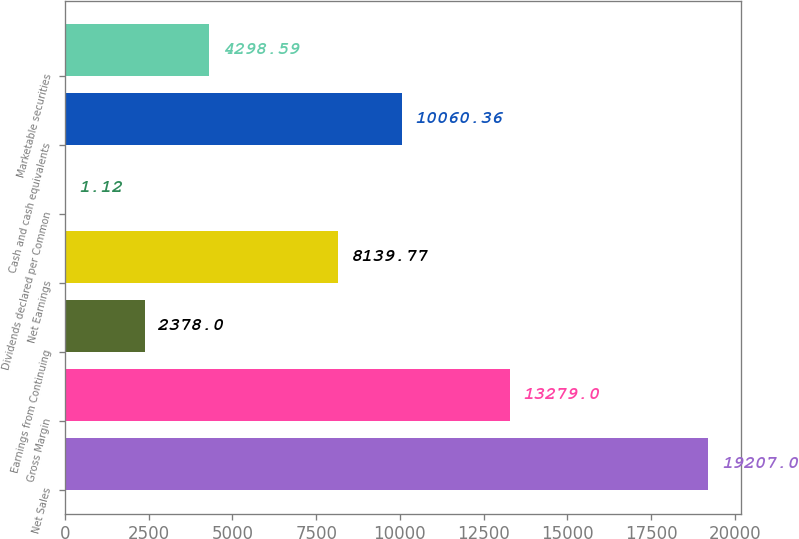Convert chart. <chart><loc_0><loc_0><loc_500><loc_500><bar_chart><fcel>Net Sales<fcel>Gross Margin<fcel>Earnings from Continuing<fcel>Net Earnings<fcel>Dividends declared per Common<fcel>Cash and cash equivalents<fcel>Marketable securities<nl><fcel>19207<fcel>13279<fcel>2378<fcel>8139.77<fcel>1.12<fcel>10060.4<fcel>4298.59<nl></chart> 